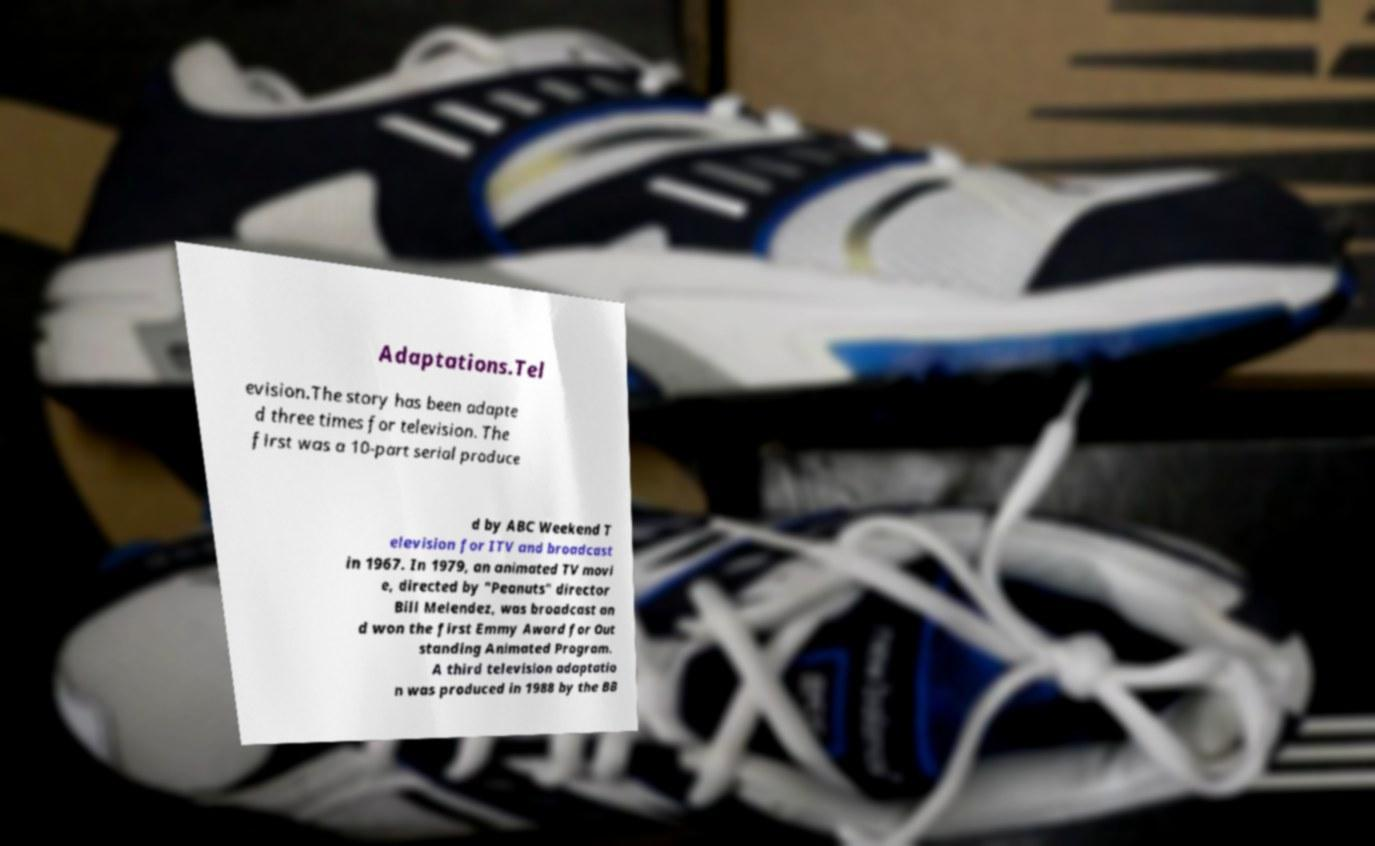Could you extract and type out the text from this image? Adaptations.Tel evision.The story has been adapte d three times for television. The first was a 10-part serial produce d by ABC Weekend T elevision for ITV and broadcast in 1967. In 1979, an animated TV movi e, directed by "Peanuts" director Bill Melendez, was broadcast an d won the first Emmy Award for Out standing Animated Program. A third television adaptatio n was produced in 1988 by the BB 